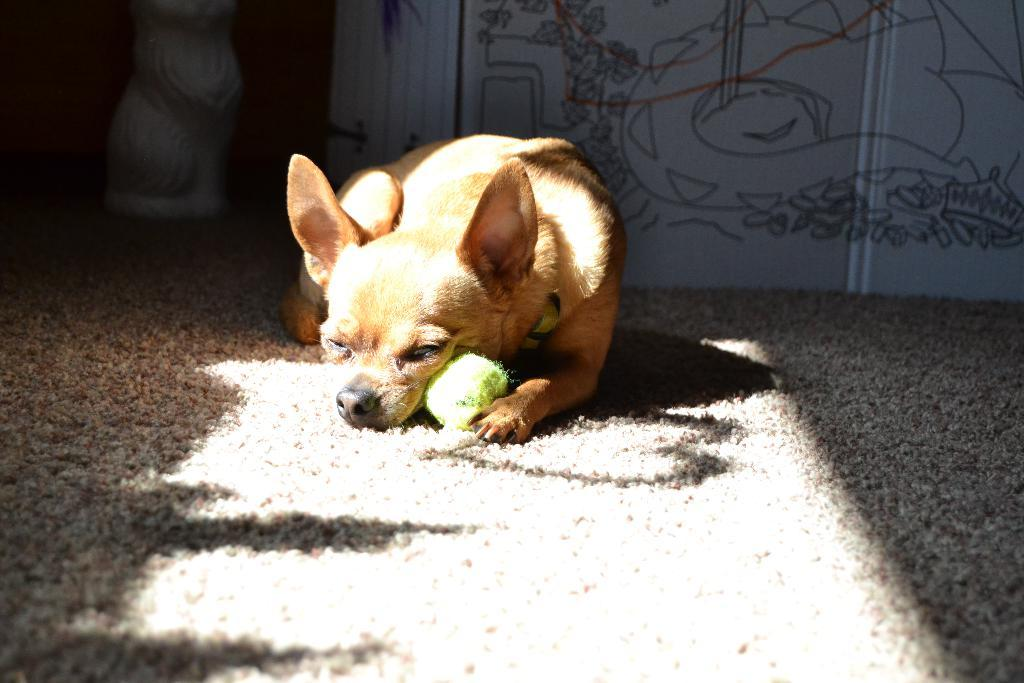What type of animal is in the image? There is a dog in the image. What color is the dog? The dog is pale brown in color. What object is in the image that the dog might play with? There is a ball in the image. What type of flooring is visible in the image? There is a carpet in the image. What type of structure is visible in the image? There is a wall in the image. Can you see a beam of light shining through the river in the image? There is no river or beam of light present in the image. 